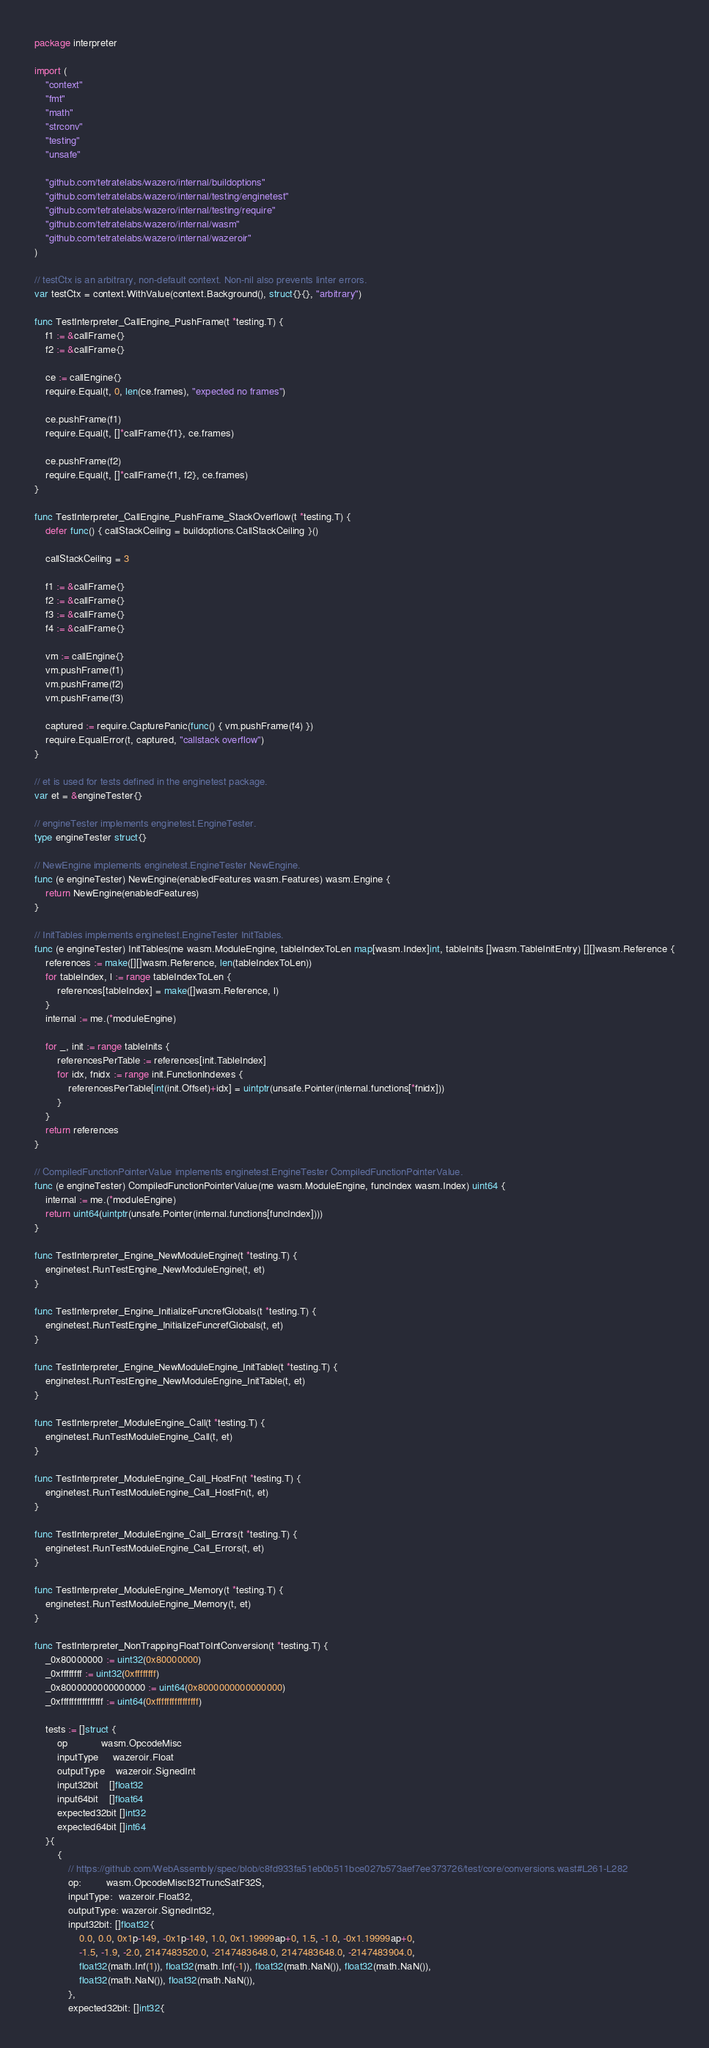Convert code to text. <code><loc_0><loc_0><loc_500><loc_500><_Go_>package interpreter

import (
	"context"
	"fmt"
	"math"
	"strconv"
	"testing"
	"unsafe"

	"github.com/tetratelabs/wazero/internal/buildoptions"
	"github.com/tetratelabs/wazero/internal/testing/enginetest"
	"github.com/tetratelabs/wazero/internal/testing/require"
	"github.com/tetratelabs/wazero/internal/wasm"
	"github.com/tetratelabs/wazero/internal/wazeroir"
)

// testCtx is an arbitrary, non-default context. Non-nil also prevents linter errors.
var testCtx = context.WithValue(context.Background(), struct{}{}, "arbitrary")

func TestInterpreter_CallEngine_PushFrame(t *testing.T) {
	f1 := &callFrame{}
	f2 := &callFrame{}

	ce := callEngine{}
	require.Equal(t, 0, len(ce.frames), "expected no frames")

	ce.pushFrame(f1)
	require.Equal(t, []*callFrame{f1}, ce.frames)

	ce.pushFrame(f2)
	require.Equal(t, []*callFrame{f1, f2}, ce.frames)
}

func TestInterpreter_CallEngine_PushFrame_StackOverflow(t *testing.T) {
	defer func() { callStackCeiling = buildoptions.CallStackCeiling }()

	callStackCeiling = 3

	f1 := &callFrame{}
	f2 := &callFrame{}
	f3 := &callFrame{}
	f4 := &callFrame{}

	vm := callEngine{}
	vm.pushFrame(f1)
	vm.pushFrame(f2)
	vm.pushFrame(f3)

	captured := require.CapturePanic(func() { vm.pushFrame(f4) })
	require.EqualError(t, captured, "callstack overflow")
}

// et is used for tests defined in the enginetest package.
var et = &engineTester{}

// engineTester implements enginetest.EngineTester.
type engineTester struct{}

// NewEngine implements enginetest.EngineTester NewEngine.
func (e engineTester) NewEngine(enabledFeatures wasm.Features) wasm.Engine {
	return NewEngine(enabledFeatures)
}

// InitTables implements enginetest.EngineTester InitTables.
func (e engineTester) InitTables(me wasm.ModuleEngine, tableIndexToLen map[wasm.Index]int, tableInits []wasm.TableInitEntry) [][]wasm.Reference {
	references := make([][]wasm.Reference, len(tableIndexToLen))
	for tableIndex, l := range tableIndexToLen {
		references[tableIndex] = make([]wasm.Reference, l)
	}
	internal := me.(*moduleEngine)

	for _, init := range tableInits {
		referencesPerTable := references[init.TableIndex]
		for idx, fnidx := range init.FunctionIndexes {
			referencesPerTable[int(init.Offset)+idx] = uintptr(unsafe.Pointer(internal.functions[*fnidx]))
		}
	}
	return references
}

// CompiledFunctionPointerValue implements enginetest.EngineTester CompiledFunctionPointerValue.
func (e engineTester) CompiledFunctionPointerValue(me wasm.ModuleEngine, funcIndex wasm.Index) uint64 {
	internal := me.(*moduleEngine)
	return uint64(uintptr(unsafe.Pointer(internal.functions[funcIndex])))
}

func TestInterpreter_Engine_NewModuleEngine(t *testing.T) {
	enginetest.RunTestEngine_NewModuleEngine(t, et)
}

func TestInterpreter_Engine_InitializeFuncrefGlobals(t *testing.T) {
	enginetest.RunTestEngine_InitializeFuncrefGlobals(t, et)
}

func TestInterpreter_Engine_NewModuleEngine_InitTable(t *testing.T) {
	enginetest.RunTestEngine_NewModuleEngine_InitTable(t, et)
}

func TestInterpreter_ModuleEngine_Call(t *testing.T) {
	enginetest.RunTestModuleEngine_Call(t, et)
}

func TestInterpreter_ModuleEngine_Call_HostFn(t *testing.T) {
	enginetest.RunTestModuleEngine_Call_HostFn(t, et)
}

func TestInterpreter_ModuleEngine_Call_Errors(t *testing.T) {
	enginetest.RunTestModuleEngine_Call_Errors(t, et)
}

func TestInterpreter_ModuleEngine_Memory(t *testing.T) {
	enginetest.RunTestModuleEngine_Memory(t, et)
}

func TestInterpreter_NonTrappingFloatToIntConversion(t *testing.T) {
	_0x80000000 := uint32(0x80000000)
	_0xffffffff := uint32(0xffffffff)
	_0x8000000000000000 := uint64(0x8000000000000000)
	_0xffffffffffffffff := uint64(0xffffffffffffffff)

	tests := []struct {
		op            wasm.OpcodeMisc
		inputType     wazeroir.Float
		outputType    wazeroir.SignedInt
		input32bit    []float32
		input64bit    []float64
		expected32bit []int32
		expected64bit []int64
	}{
		{
			// https://github.com/WebAssembly/spec/blob/c8fd933fa51eb0b511bce027b573aef7ee373726/test/core/conversions.wast#L261-L282
			op:         wasm.OpcodeMiscI32TruncSatF32S,
			inputType:  wazeroir.Float32,
			outputType: wazeroir.SignedInt32,
			input32bit: []float32{
				0.0, 0.0, 0x1p-149, -0x1p-149, 1.0, 0x1.19999ap+0, 1.5, -1.0, -0x1.19999ap+0,
				-1.5, -1.9, -2.0, 2147483520.0, -2147483648.0, 2147483648.0, -2147483904.0,
				float32(math.Inf(1)), float32(math.Inf(-1)), float32(math.NaN()), float32(math.NaN()),
				float32(math.NaN()), float32(math.NaN()),
			},
			expected32bit: []int32{</code> 